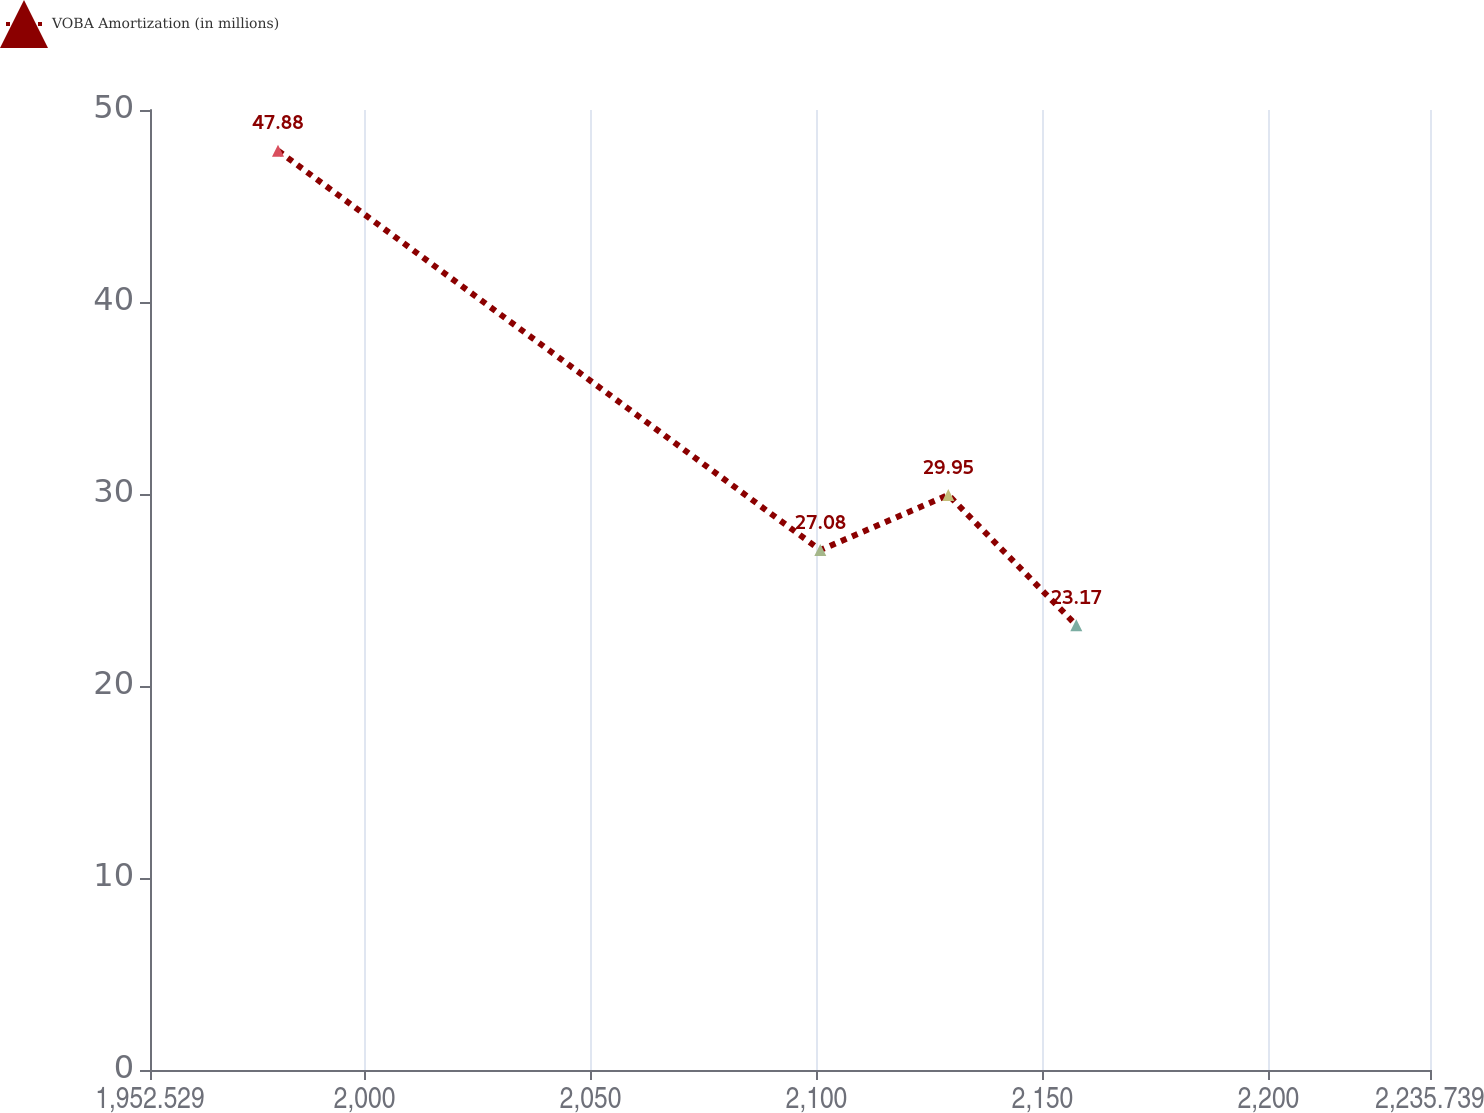Convert chart to OTSL. <chart><loc_0><loc_0><loc_500><loc_500><line_chart><ecel><fcel>VOBA Amortization (in millions)<nl><fcel>1980.85<fcel>47.88<nl><fcel>2100.84<fcel>27.08<nl><fcel>2129.16<fcel>29.95<nl><fcel>2157.48<fcel>23.17<nl><fcel>2264.06<fcel>19.15<nl></chart> 